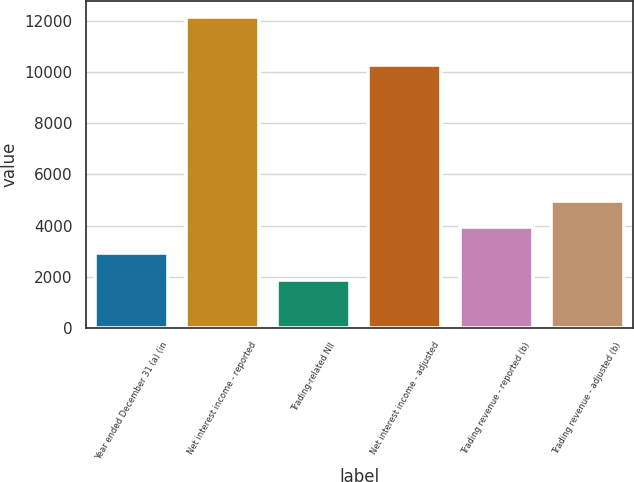<chart> <loc_0><loc_0><loc_500><loc_500><bar_chart><fcel>Year ended December 31 (a) (in<fcel>Net interest income - reported<fcel>Trading-related NII<fcel>Net interest income - adjusted<fcel>Trading revenue - reported (b)<fcel>Trading revenue - adjusted (b)<nl><fcel>2909.8<fcel>12178<fcel>1880<fcel>10298<fcel>3939.6<fcel>4969.4<nl></chart> 